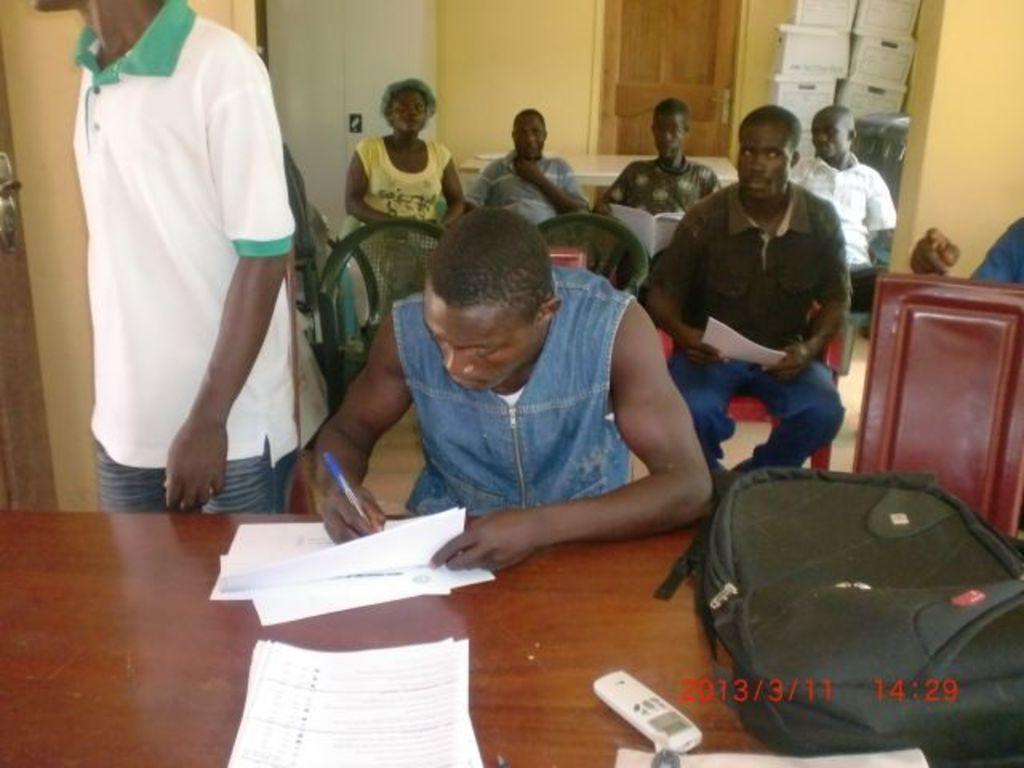Please provide a concise description of this image. There are few people sitting on the chairs and a person standing. This is a table with the papers, remote and a bag. On the right side of the image, that looks like a wooden object. In the background, I think this is a door with a door handle. These look like the cardboard boxes, which are white in color. I think this is the wardrobe. I can see the watermark on the image. 